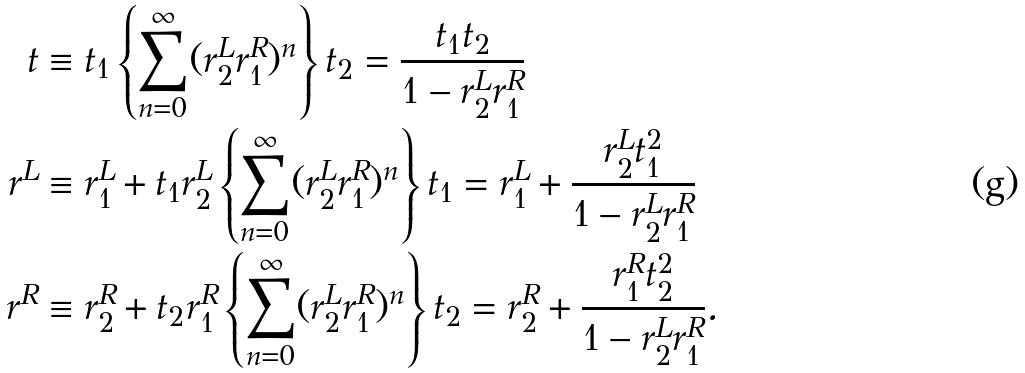<formula> <loc_0><loc_0><loc_500><loc_500>t & \equiv t _ { 1 } \left \{ \sum _ { n = 0 } ^ { \infty } ( r ^ { L } _ { 2 } r ^ { R } _ { 1 } ) ^ { n } \right \} t _ { 2 } = \frac { t _ { 1 } t _ { 2 } } { 1 - r ^ { L } _ { 2 } r ^ { R } _ { 1 } } \\ r ^ { L } & \equiv r ^ { L } _ { 1 } + t _ { 1 } r ^ { L } _ { 2 } \left \{ \sum _ { n = 0 } ^ { \infty } ( r ^ { L } _ { 2 } r ^ { R } _ { 1 } ) ^ { n } \right \} t _ { 1 } = r ^ { L } _ { 1 } + \frac { r ^ { L } _ { 2 } t _ { 1 } ^ { 2 } } { 1 - r ^ { L } _ { 2 } r ^ { R } _ { 1 } } \\ r ^ { R } & \equiv r ^ { R } _ { 2 } + t _ { 2 } r ^ { R } _ { 1 } \left \{ \sum _ { n = 0 } ^ { \infty } ( r ^ { L } _ { 2 } r ^ { R } _ { 1 } ) ^ { n } \right \} t _ { 2 } = r ^ { R } _ { 2 } + \frac { r ^ { R } _ { 1 } t _ { 2 } ^ { 2 } } { 1 - r ^ { L } _ { 2 } r ^ { R } _ { 1 } } .</formula> 